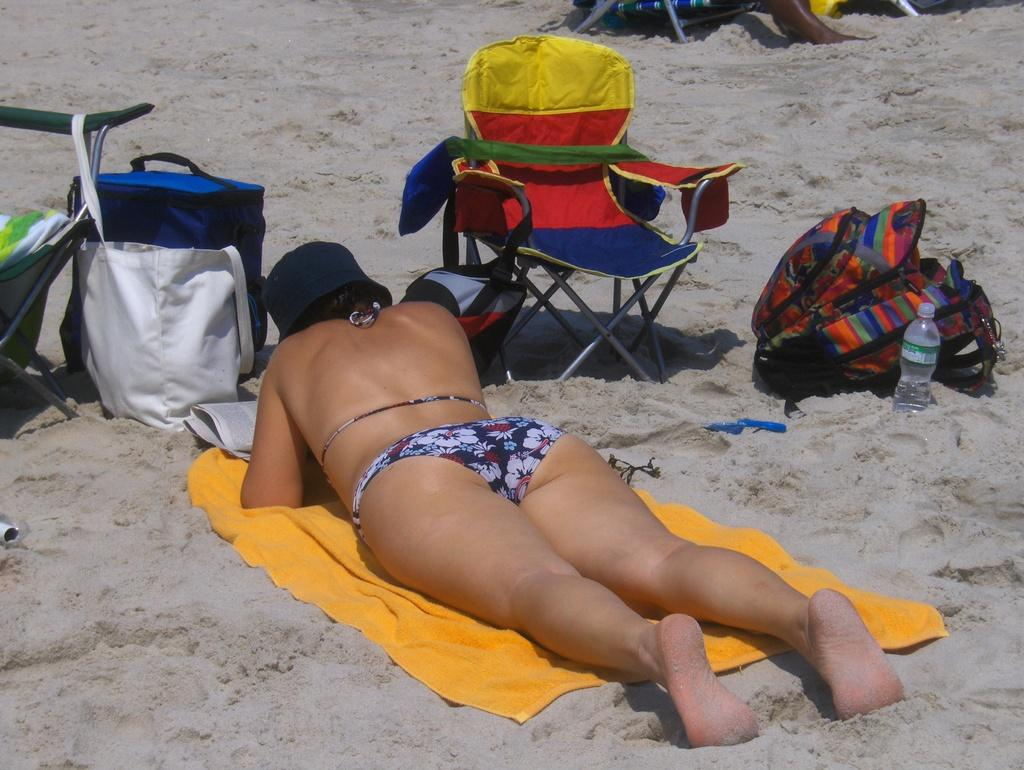What is the woman doing in the image? The woman is lying on a cloth in the image. What type of furniture is present in the image? There is a chair in the image. What items can be seen that might be used for carrying or storage? There are bags in the image. Can you describe any other objects visible in the image? There are other objects visible in the image, but their specific details are not mentioned in the provided facts. What position does the loaf take in the image? There is no loaf present in the image, so it cannot be determined what position it might take. 